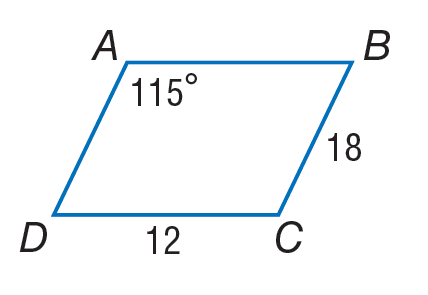Answer the mathemtical geometry problem and directly provide the correct option letter.
Question: Use parallelogram A B C D to find A B.
Choices: A: 6 B: 12 C: 18 D: 115 B 